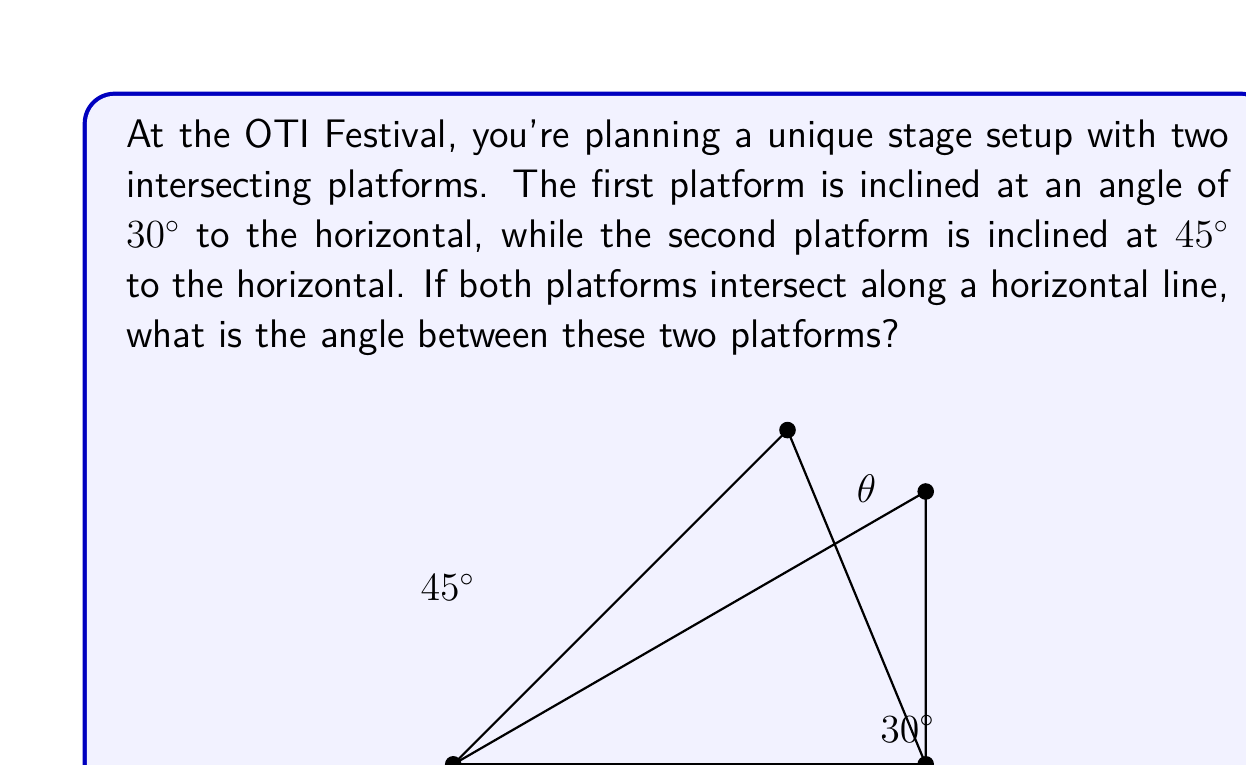Can you solve this math problem? To solve this problem, we'll use the concept of dihedral angles in solid geometry. The angle between two intersecting planes is equal to the angle between their normal vectors. Let's approach this step-by-step:

1) First, we need to find the normal vectors of both planes:
   - For the 30° platform: $\vec{n_1} = (\sin 30°, 0, \cos 30°)$
   - For the 45° platform: $\vec{n_2} = (\sin 45°, 0, \cos 45°)$

2) We can simplify these vectors:
   $\vec{n_1} = (0.5, 0, \frac{\sqrt{3}}{2})$
   $\vec{n_2} = (\frac{\sqrt{2}}{2}, 0, \frac{\sqrt{2}}{2})$

3) The angle $\theta$ between these normal vectors is given by the dot product formula:

   $$\cos \theta = \frac{\vec{n_1} \cdot \vec{n_2}}{|\vec{n_1}||\vec{n_2}|}$$

4) Let's calculate the dot product:
   $\vec{n_1} \cdot \vec{n_2} = 0.5 \cdot \frac{\sqrt{2}}{2} + 0 + \frac{\sqrt{3}}{2} \cdot \frac{\sqrt{2}}{2} = \frac{\sqrt{2}}{4} + \frac{\sqrt{6}}{4}$

5) Now, the magnitudes:
   $|\vec{n_1}| = \sqrt{0.5^2 + (\frac{\sqrt{3}}{2})^2} = 1$
   $|\vec{n_2}| = \sqrt{(\frac{\sqrt{2}}{2})^2 + (\frac{\sqrt{2}}{2})^2} = 1$

6) Substituting into the formula:
   $$\cos \theta = \frac{\frac{\sqrt{2}}{4} + \frac{\sqrt{6}}{4}}{1 \cdot 1} = \frac{\sqrt{2} + \sqrt{6}}{4}$$

7) Finally, we can find $\theta$:
   $$\theta = \arccos(\frac{\sqrt{2} + \sqrt{6}}{4})$$

8) Using a calculator, we can evaluate this:
   $\theta \approx 15.0°$
Answer: The angle between the two stage platforms is approximately $15.0°$. 